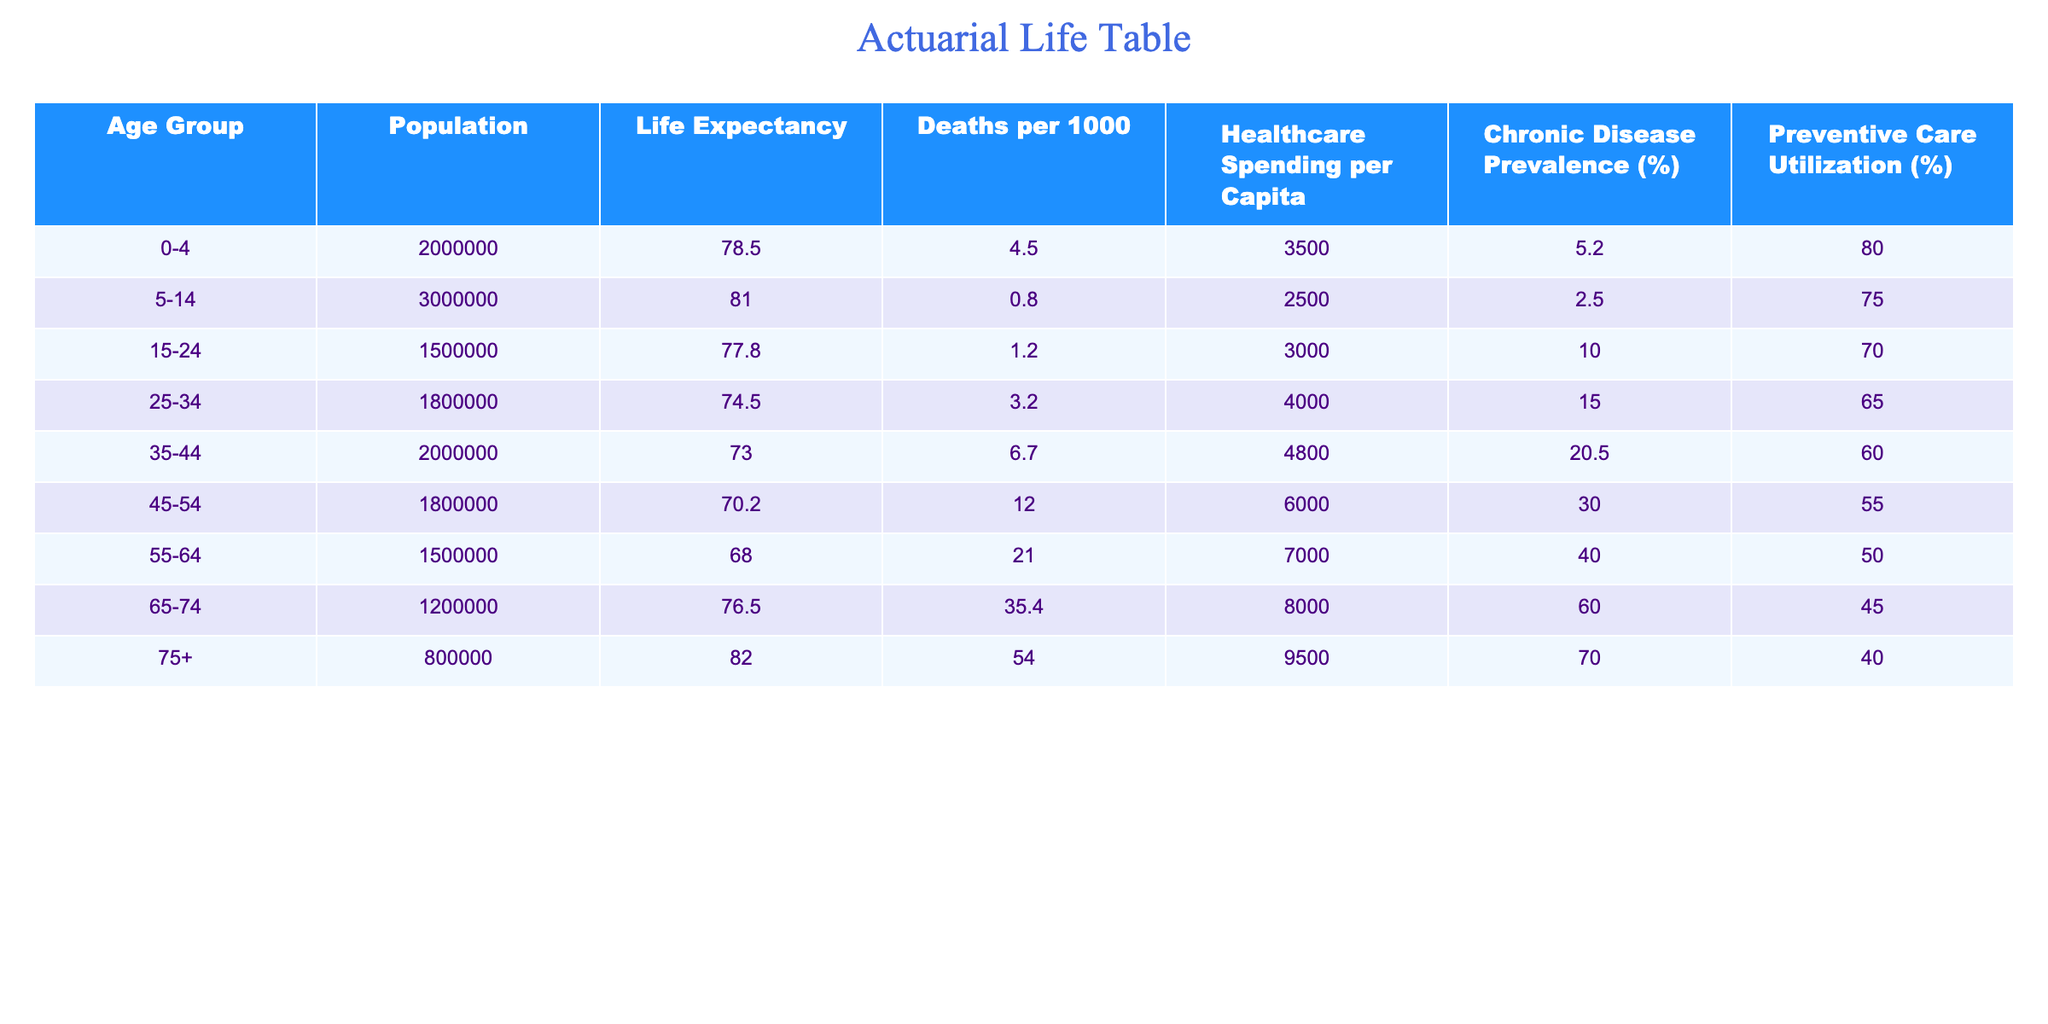What is the life expectancy for the age group 55-64? The life expectancy for the age group 55-64 is given directly in the table under the respective column, which shows a value of 68.0.
Answer: 68.0 What is the death rate per 1000 for individuals aged 45-54? The death rate per 1000 for individuals aged 45-54 can be found in the table and is listed as 12.0.
Answer: 12.0 Which age group has the highest healthcare spending per capita? By looking at the 'Healthcare Spending per Capita' column, the age group 75+ has the highest spending at 9500.
Answer: 75+ What is the average life expectancy across all age groups? To calculate the average life expectancy, sum all life expectancies (78.5 + 81.0 + 77.8 + 74.5 + 73.0 + 70.2 + 68.0 + 76.5 + 82.0) which equals 82.2, and divide by the number of groups (9). The average life expectancy is approximately 76.52.
Answer: 76.52 Is the preventive care utilization percentage for the age group 35-44 greater than that for the age group 55-64? The preventive care utilization percentage for 35-44 is 60%, while for 55-64 it is 50%. Therefore, 60% is greater than 50%.
Answer: Yes Which age group has the highest prevalence of chronic disease? The age group 75+ has the highest chronic disease prevalence at 70.0%. This information is found directly in the table.
Answer: 75+ What is the difference in deaths per 1000 between the age groups 0-4 and 75+? The death rate for 0-4 is 4.5, and for 75+ it is 54.0. The difference is calculated as 54.0 - 4.5 = 49.5.
Answer: 49.5 What proportion of the population is aged 15-24 if the total population is the sum of all age groups? First, sum the population of all age groups which totals to 10,000,000. The population for age group 15-24 is 1,500,000. Therefore, the proportion is 1,500,000 / 10,000,000 = 0.15 or 15%.
Answer: 15% If healthcare spending is a primary factor for longevity, what can we infer about the age group 55-64 compared to 45-54 given their spending and life expectancy? The age group 55-64 has a life expectancy of 68.0 and a healthcare spending of 7,000, while the age group 45-54 has a life expectancy of 70.2 with a spending of 6,000. Although 55-64 has higher spending, it has lower life expectancy compared to 45-54. This suggests that higher spending does not necessarily correlate with higher life expectancy.
Answer: Higher spending in 55-64 does not result in higher life expectancy 